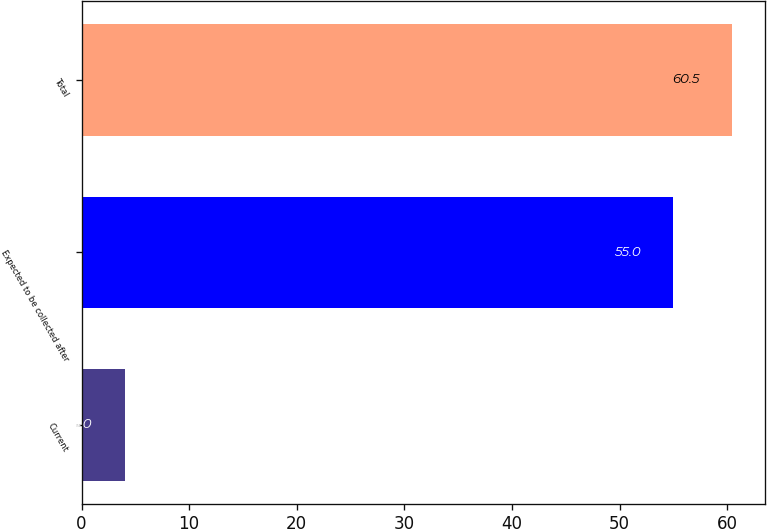Convert chart. <chart><loc_0><loc_0><loc_500><loc_500><bar_chart><fcel>Current<fcel>Expected to be collected after<fcel>Total<nl><fcel>4<fcel>55<fcel>60.5<nl></chart> 